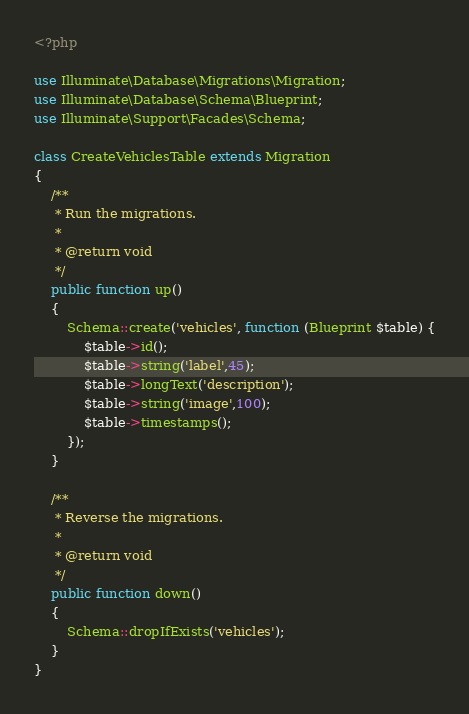<code> <loc_0><loc_0><loc_500><loc_500><_PHP_><?php

use Illuminate\Database\Migrations\Migration;
use Illuminate\Database\Schema\Blueprint;
use Illuminate\Support\Facades\Schema;

class CreateVehiclesTable extends Migration
{
    /**
     * Run the migrations.
     *
     * @return void
     */
    public function up()
    {
        Schema::create('vehicles', function (Blueprint $table) {
            $table->id();
            $table->string('label',45);
            $table->longText('description');
            $table->string('image',100);
            $table->timestamps();
        });
    }

    /**
     * Reverse the migrations.
     *
     * @return void
     */
    public function down()
    {
        Schema::dropIfExists('vehicles');
    }
}
</code> 